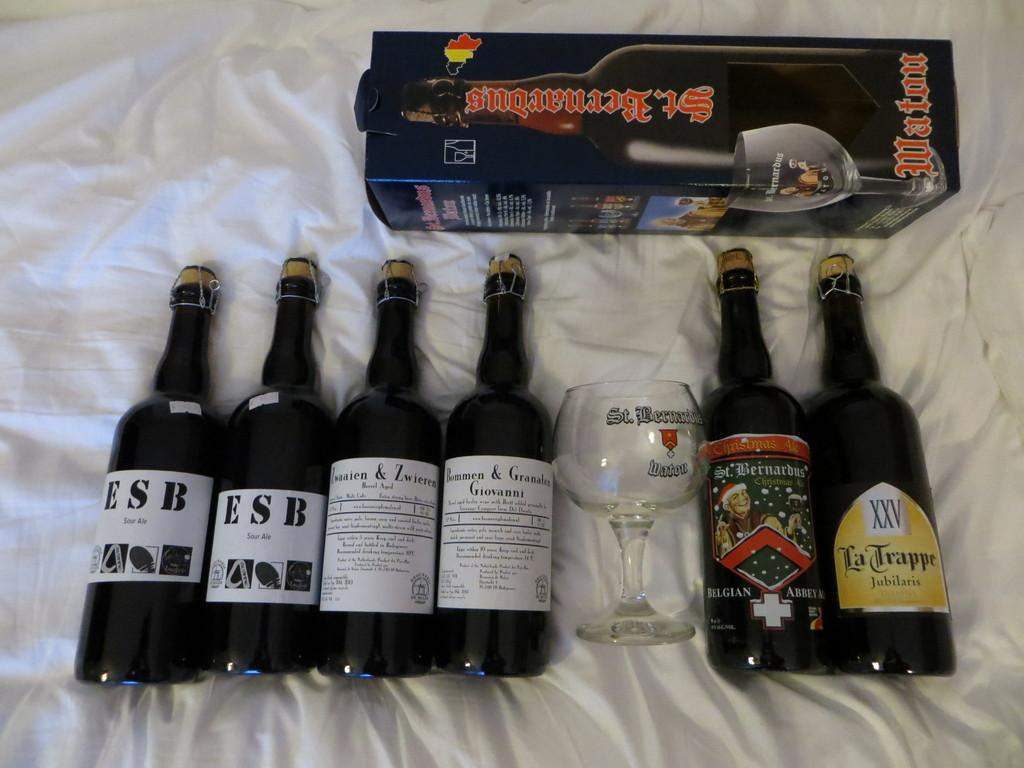<image>
Describe the image concisely. the word trappe that is on a bottle 